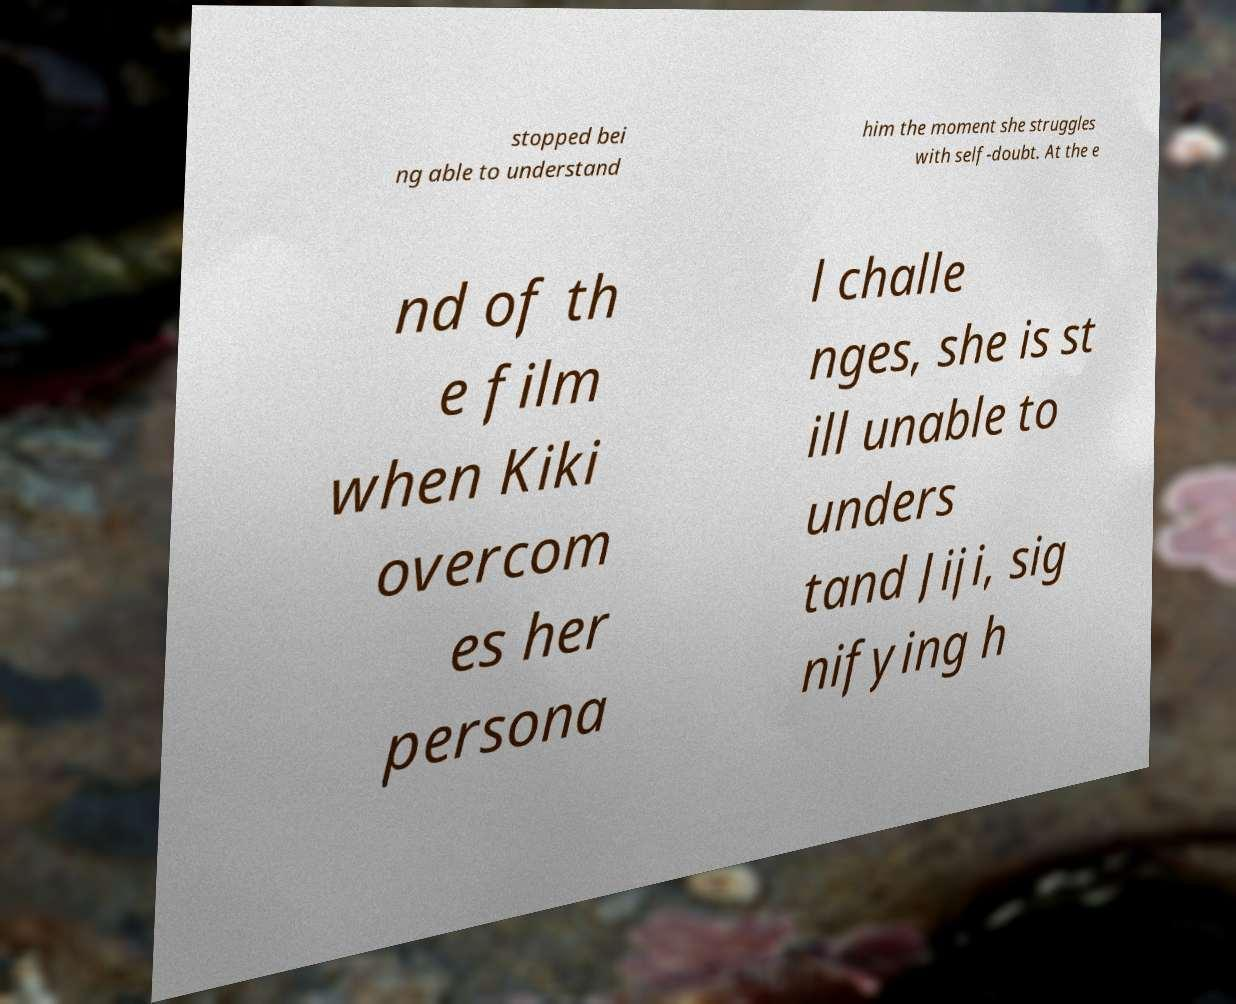Can you accurately transcribe the text from the provided image for me? stopped bei ng able to understand him the moment she struggles with self-doubt. At the e nd of th e film when Kiki overcom es her persona l challe nges, she is st ill unable to unders tand Jiji, sig nifying h 